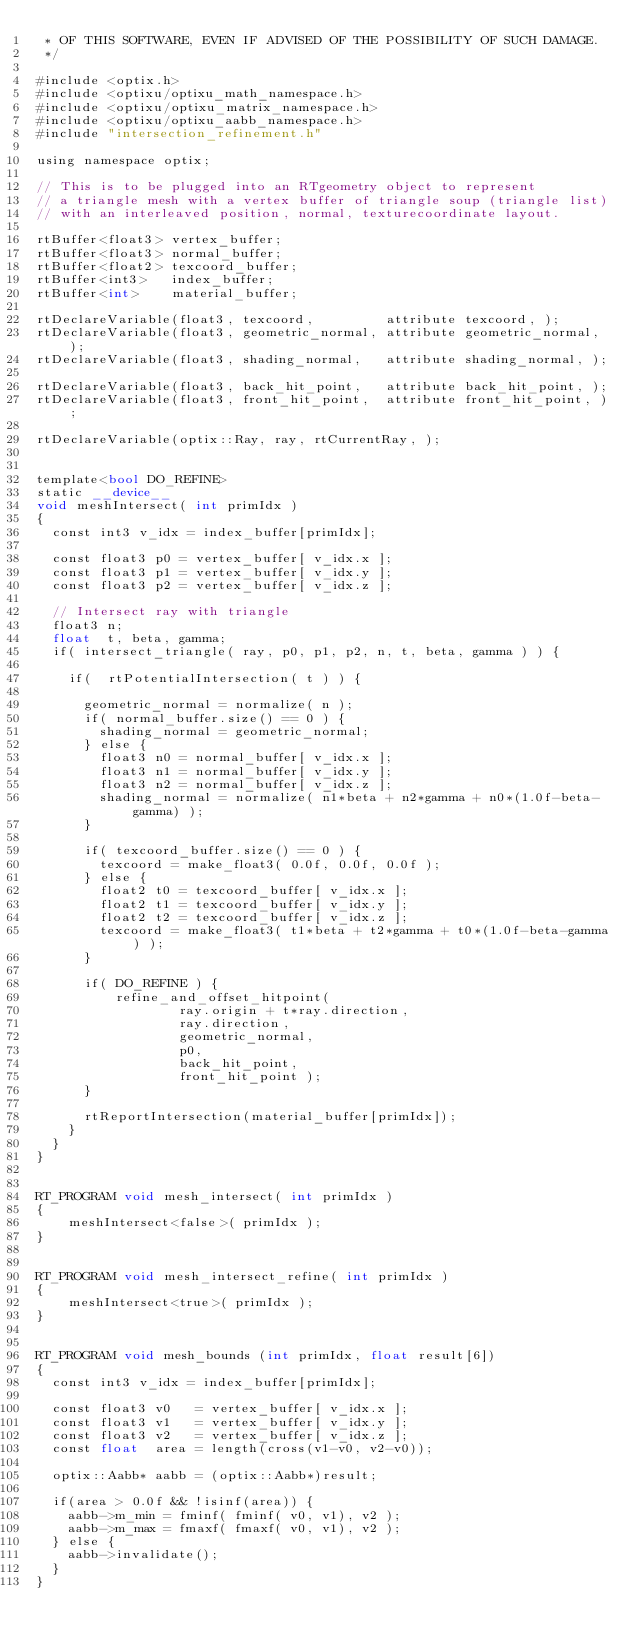Convert code to text. <code><loc_0><loc_0><loc_500><loc_500><_Cuda_> * OF THIS SOFTWARE, EVEN IF ADVISED OF THE POSSIBILITY OF SUCH DAMAGE.
 */

#include <optix.h>
#include <optixu/optixu_math_namespace.h>
#include <optixu/optixu_matrix_namespace.h>
#include <optixu/optixu_aabb_namespace.h>
#include "intersection_refinement.h"

using namespace optix;

// This is to be plugged into an RTgeometry object to represent
// a triangle mesh with a vertex buffer of triangle soup (triangle list)
// with an interleaved position, normal, texturecoordinate layout.

rtBuffer<float3> vertex_buffer;     
rtBuffer<float3> normal_buffer;
rtBuffer<float2> texcoord_buffer;
rtBuffer<int3>   index_buffer;
rtBuffer<int>    material_buffer;

rtDeclareVariable(float3, texcoord,         attribute texcoord, ); 
rtDeclareVariable(float3, geometric_normal, attribute geometric_normal, ); 
rtDeclareVariable(float3, shading_normal,   attribute shading_normal, ); 

rtDeclareVariable(float3, back_hit_point,   attribute back_hit_point, ); 
rtDeclareVariable(float3, front_hit_point,  attribute front_hit_point, ); 

rtDeclareVariable(optix::Ray, ray, rtCurrentRay, );


template<bool DO_REFINE>
static __device__
void meshIntersect( int primIdx )
{
  const int3 v_idx = index_buffer[primIdx];

  const float3 p0 = vertex_buffer[ v_idx.x ];
  const float3 p1 = vertex_buffer[ v_idx.y ];
  const float3 p2 = vertex_buffer[ v_idx.z ];

  // Intersect ray with triangle
  float3 n;
  float  t, beta, gamma;
  if( intersect_triangle( ray, p0, p1, p2, n, t, beta, gamma ) ) {

    if(  rtPotentialIntersection( t ) ) {

      geometric_normal = normalize( n );
      if( normal_buffer.size() == 0 ) {
        shading_normal = geometric_normal; 
      } else {
        float3 n0 = normal_buffer[ v_idx.x ];
        float3 n1 = normal_buffer[ v_idx.y ];
        float3 n2 = normal_buffer[ v_idx.z ];
        shading_normal = normalize( n1*beta + n2*gamma + n0*(1.0f-beta-gamma) );
      }

      if( texcoord_buffer.size() == 0 ) {
        texcoord = make_float3( 0.0f, 0.0f, 0.0f );
      } else {
        float2 t0 = texcoord_buffer[ v_idx.x ];
        float2 t1 = texcoord_buffer[ v_idx.y ];
        float2 t2 = texcoord_buffer[ v_idx.z ];
        texcoord = make_float3( t1*beta + t2*gamma + t0*(1.0f-beta-gamma) );
      }

      if( DO_REFINE ) {
          refine_and_offset_hitpoint(
                  ray.origin + t*ray.direction,
                  ray.direction,
                  geometric_normal,
                  p0,
                  back_hit_point,
                  front_hit_point );
      }

      rtReportIntersection(material_buffer[primIdx]);
    }
  }
}


RT_PROGRAM void mesh_intersect( int primIdx )
{
    meshIntersect<false>( primIdx );
}


RT_PROGRAM void mesh_intersect_refine( int primIdx )
{
    meshIntersect<true>( primIdx );
}


RT_PROGRAM void mesh_bounds (int primIdx, float result[6])
{
  const int3 v_idx = index_buffer[primIdx];

  const float3 v0   = vertex_buffer[ v_idx.x ];
  const float3 v1   = vertex_buffer[ v_idx.y ];
  const float3 v2   = vertex_buffer[ v_idx.z ];
  const float  area = length(cross(v1-v0, v2-v0));

  optix::Aabb* aabb = (optix::Aabb*)result;
  
  if(area > 0.0f && !isinf(area)) {
    aabb->m_min = fminf( fminf( v0, v1), v2 );
    aabb->m_max = fmaxf( fmaxf( v0, v1), v2 );
  } else {
    aabb->invalidate();
  }
}

</code> 